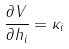Convert formula to latex. <formula><loc_0><loc_0><loc_500><loc_500>\frac { \partial V } { \partial h _ { i } } = \kappa _ { i }</formula> 